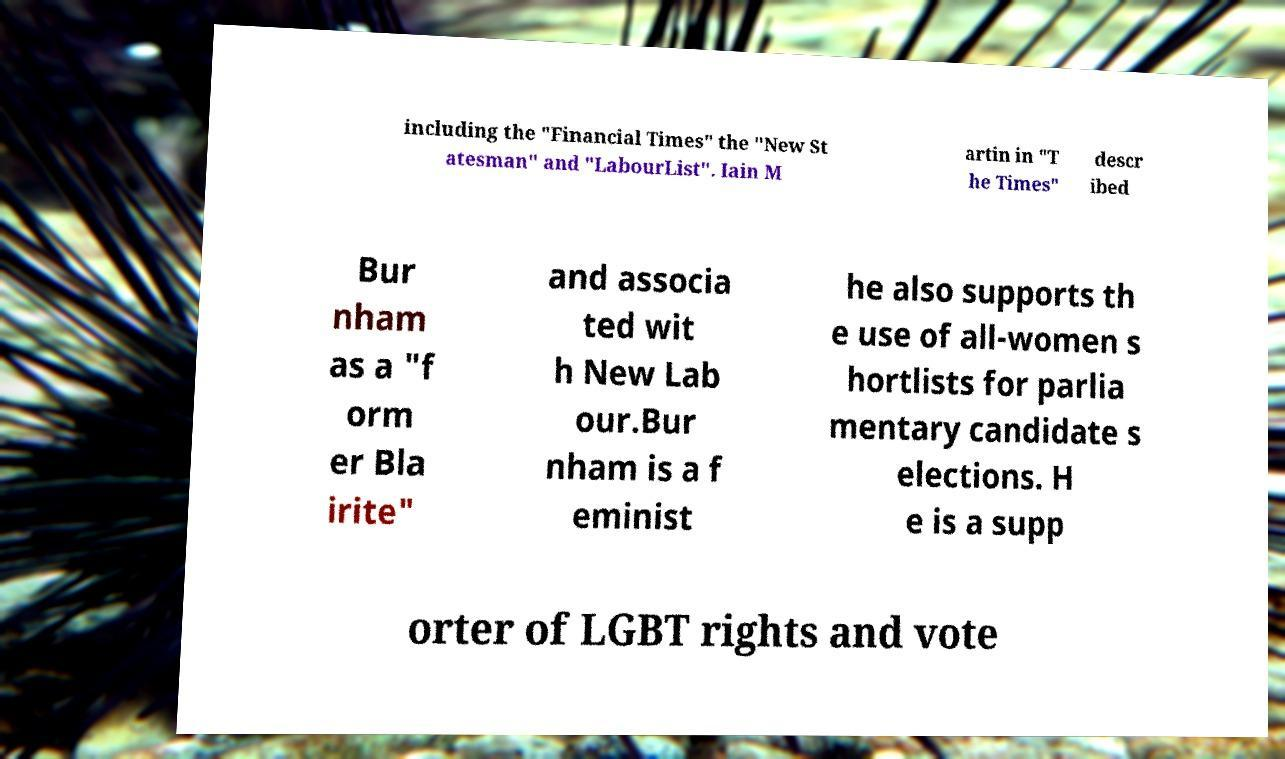Can you read and provide the text displayed in the image?This photo seems to have some interesting text. Can you extract and type it out for me? including the "Financial Times" the "New St atesman" and "LabourList". Iain M artin in "T he Times" descr ibed Bur nham as a "f orm er Bla irite" and associa ted wit h New Lab our.Bur nham is a f eminist he also supports th e use of all-women s hortlists for parlia mentary candidate s elections. H e is a supp orter of LGBT rights and vote 